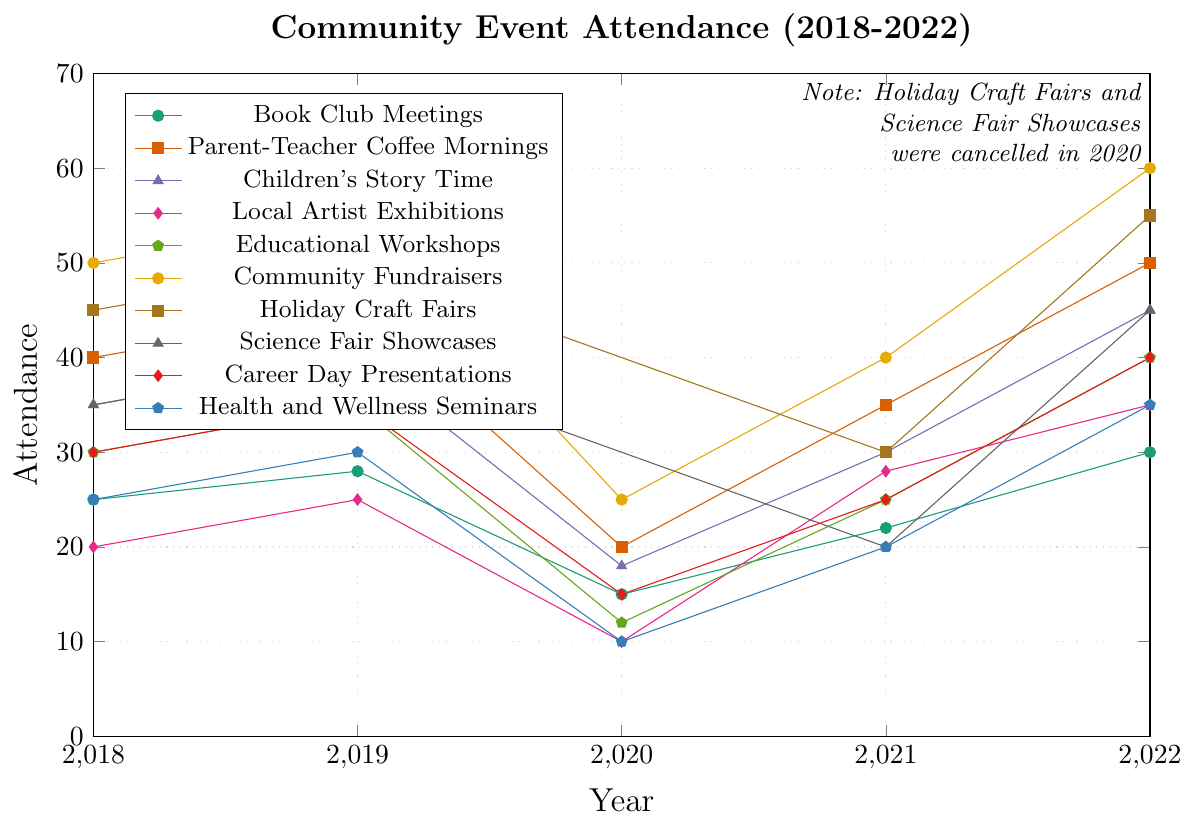What event had the highest attendance in 2022? Look at the endpoint for the year 2022 for all lines. The line representing "Community Fundraisers" reaches the highest point.
Answer: Community Fundraisers How many events saw an increase in attendance from 2021 to 2022? Check if the lines from 2021 to 2022 are ascending for each event. Book Club Meetings, Parent-Teacher Coffee Mornings, Children's Story Time, Local Artist Exhibitions, Educational Workshops, Community Fundraisers, Holiday Craft Fairs, Science Fair Showcases, Career Day Presentations, and Health and Wellness Seminars all show an increase. That's 10 events.
Answer: 10 Which event had the biggest drop in attendance from 2019 to 2020? Find the steepest downward slope between 2019 and 2020 among all lines. The "Parent-Teacher Coffee Mornings" had a drop from 45 to 20, which is the highest.
Answer: Parent-Teacher Coffee Mornings What is the average attendance for Educational Workshops over the 5 years? Add the educational workshop attendance numbers from 2018 to 2022: (30+35+12+25+40) and divide the sum by 5. The sum is 142. 142 / 5 = 28.4
Answer: 28.4 Between which two consecutive years did Holiday Craft Fairs see the greatest change in attendance? Observe the differences in attendance for Holiday Craft Fairs between each year pair. The greatest change is from 2021 to 2022 (25 to 55, a change of 25).
Answer: 2021 to 2022 Comparing Children's Story Time and Science Fair Showcases, which had higher attendance in 2021? Check the 2021 attendance for both Children's Story Time and Science Fair Showcases. Children's Story Time had 30, and Science Fair Showcases had 20.
Answer: Children's Story Time What was the total attendance for all events in 2020? Sum the attendance for each event in 2020. This includes all events except "Holiday Craft Fairs" and "Science Fair Showcases" for that year. (15 + 20 + 18 + 10 + 12 + 25 + 15 + 10) =  125
Answer: 125 Which events had a consistent increase in attendance from 2018 to 2022? Identify the lines that show a consistent upward trend for every year from 2018 to 2022. Only Community Fundraisers meet this criterion.
Answer: Community Fundraisers What is the difference in attendance between Book Club Meetings and Local Artist Exhibitions in 2022? Compare the attendance for both events in 2022. Book Club Meetings had 30, and Local Artist Exhibitions had 35. 35 - 30 = 5
Answer: 5 How did the attendance for Career Day Presentations change from 2019 to 2020 and then from 2020 to 2021? Check the numbers for Career Day Presentations for those years. From 2019 to 2020, the attendance dropped from 35 to 15 (a decrease of 20). From 2020 to 2021, it increased from 15 to 25 (an increase of 10).
Answer: Decreased by 20 and then increased by 10 